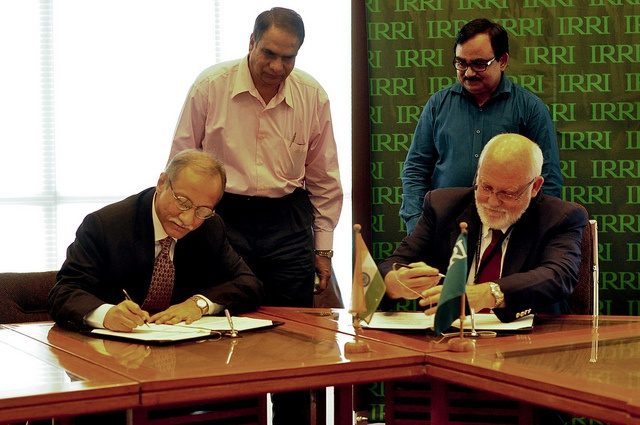Describe the objects in this image and their specific colors. I can see people in white, black, tan, brown, and maroon tones, people in white, black, brown, maroon, and tan tones, people in white, black, brown, maroon, and tan tones, people in white, black, teal, darkblue, and maroon tones, and chair in white, black, maroon, and gray tones in this image. 